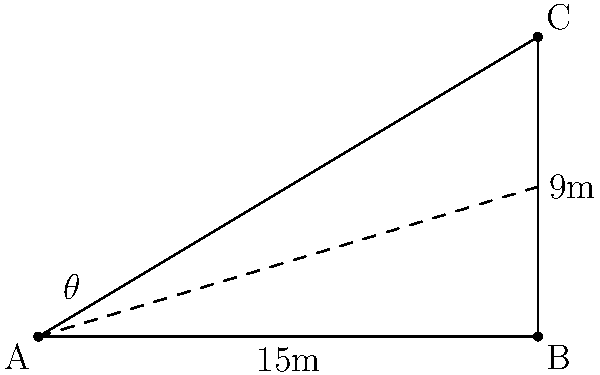In a virtual 3D scene, a camera is positioned at point A, looking at an object at point C. The horizontal distance from A to B is 15 meters, and the vertical distance from B to C is 9 meters. Calculate the angle of elevation ($\theta$) for the camera to look directly at the object. To solve this problem, we'll use the tangent function from trigonometry. The tangent of an angle in a right triangle is the ratio of the opposite side to the adjacent side.

Step 1: Identify the sides of the right triangle.
- Opposite side (vertical distance) = 9 meters
- Adjacent side (horizontal distance) = 15 meters

Step 2: Set up the tangent equation.
$$\tan(\theta) = \frac{\text{opposite}}{\text{adjacent}} = \frac{9}{15}$$

Step 3: Solve for $\theta$ using the inverse tangent (arctan or $\tan^{-1}$) function.
$$\theta = \tan^{-1}\left(\frac{9}{15}\right)$$

Step 4: Calculate the result.
$$\theta = \tan^{-1}(0.6) \approx 30.96^\circ$$

Therefore, the angle of elevation for the camera to look directly at the object is approximately 30.96 degrees.
Answer: $30.96^\circ$ 